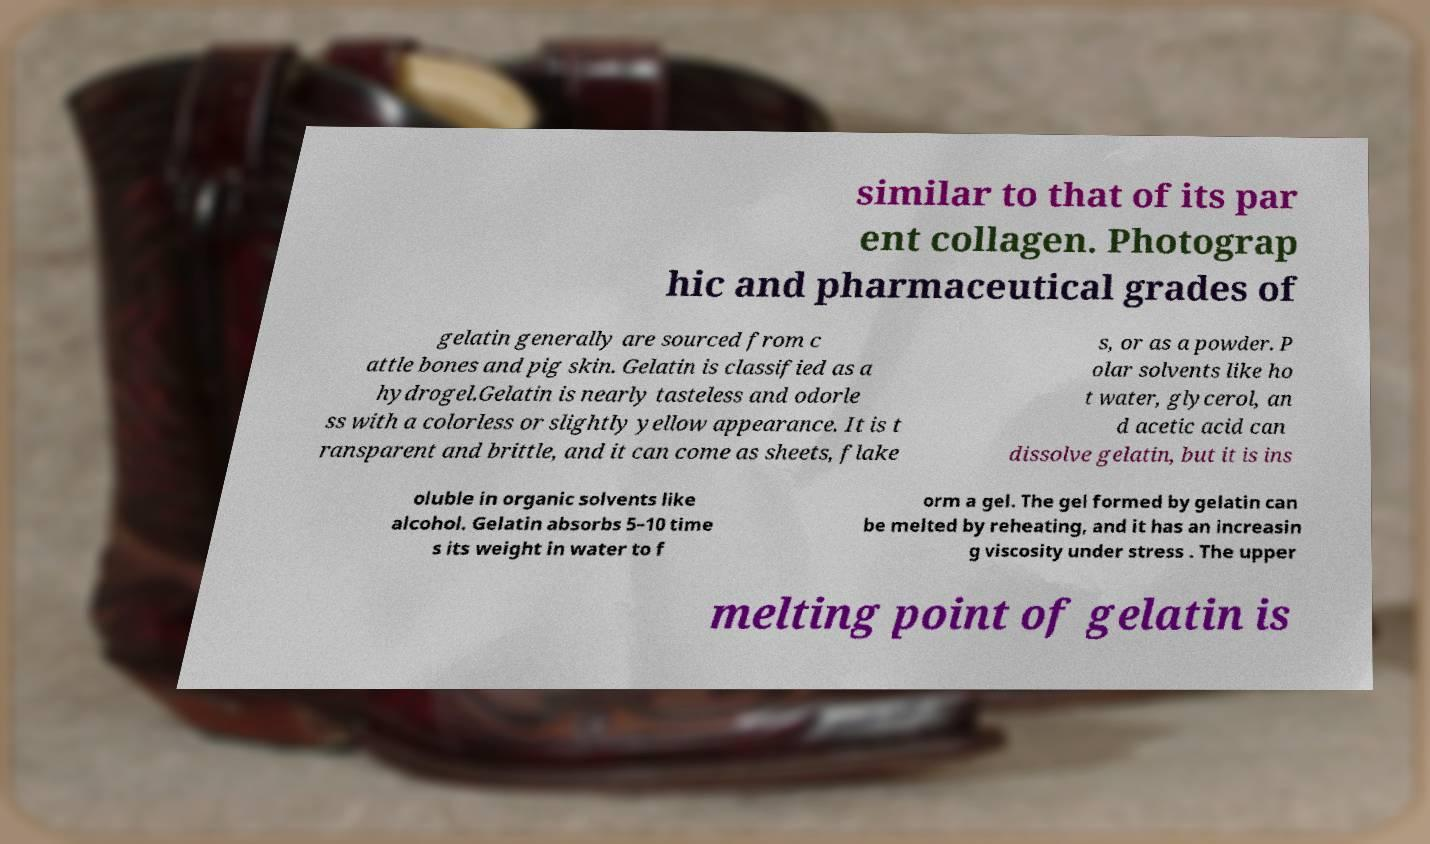Could you assist in decoding the text presented in this image and type it out clearly? similar to that of its par ent collagen. Photograp hic and pharmaceutical grades of gelatin generally are sourced from c attle bones and pig skin. Gelatin is classified as a hydrogel.Gelatin is nearly tasteless and odorle ss with a colorless or slightly yellow appearance. It is t ransparent and brittle, and it can come as sheets, flake s, or as a powder. P olar solvents like ho t water, glycerol, an d acetic acid can dissolve gelatin, but it is ins oluble in organic solvents like alcohol. Gelatin absorbs 5–10 time s its weight in water to f orm a gel. The gel formed by gelatin can be melted by reheating, and it has an increasin g viscosity under stress . The upper melting point of gelatin is 